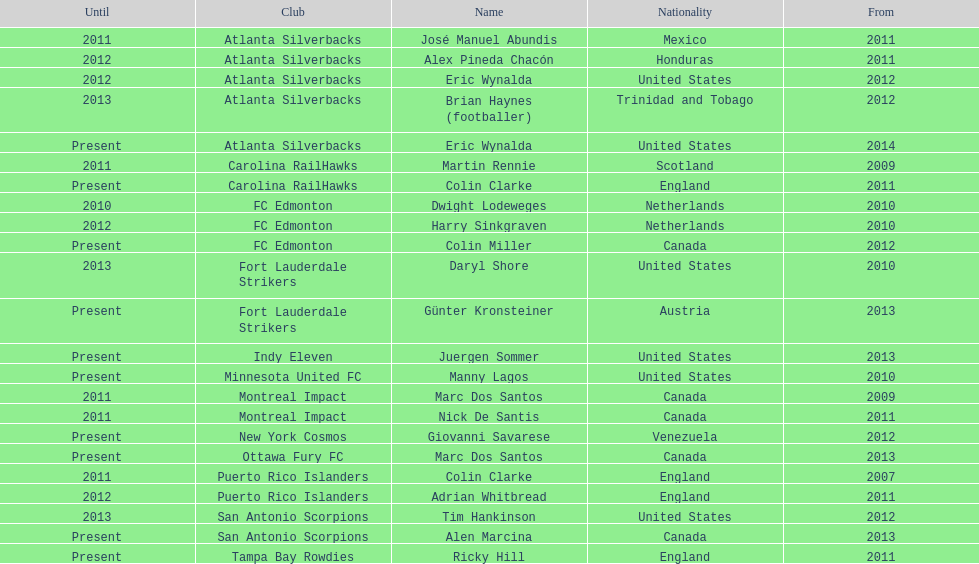Who coached the silverbacks longer, abundis or chacon? Chacon. 